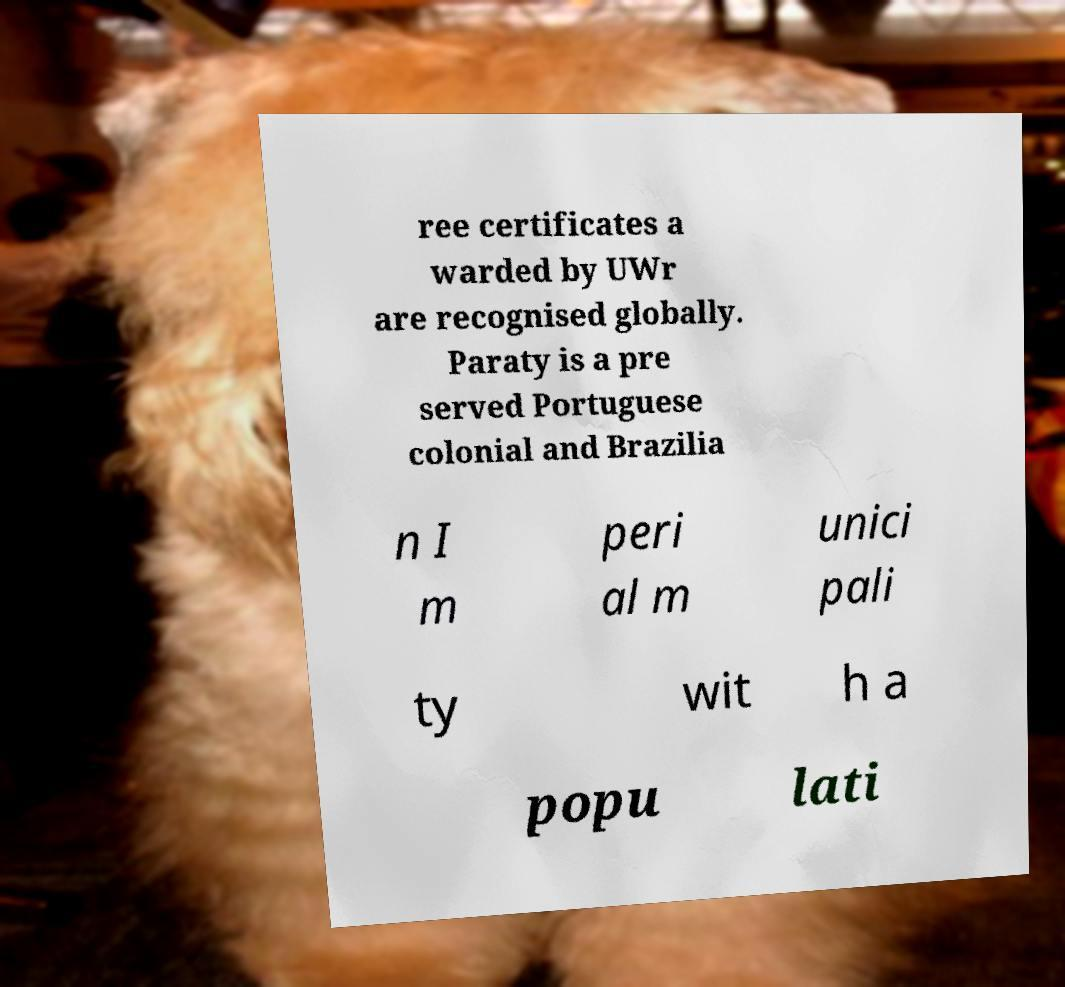What messages or text are displayed in this image? I need them in a readable, typed format. ree certificates a warded by UWr are recognised globally. Paraty is a pre served Portuguese colonial and Brazilia n I m peri al m unici pali ty wit h a popu lati 